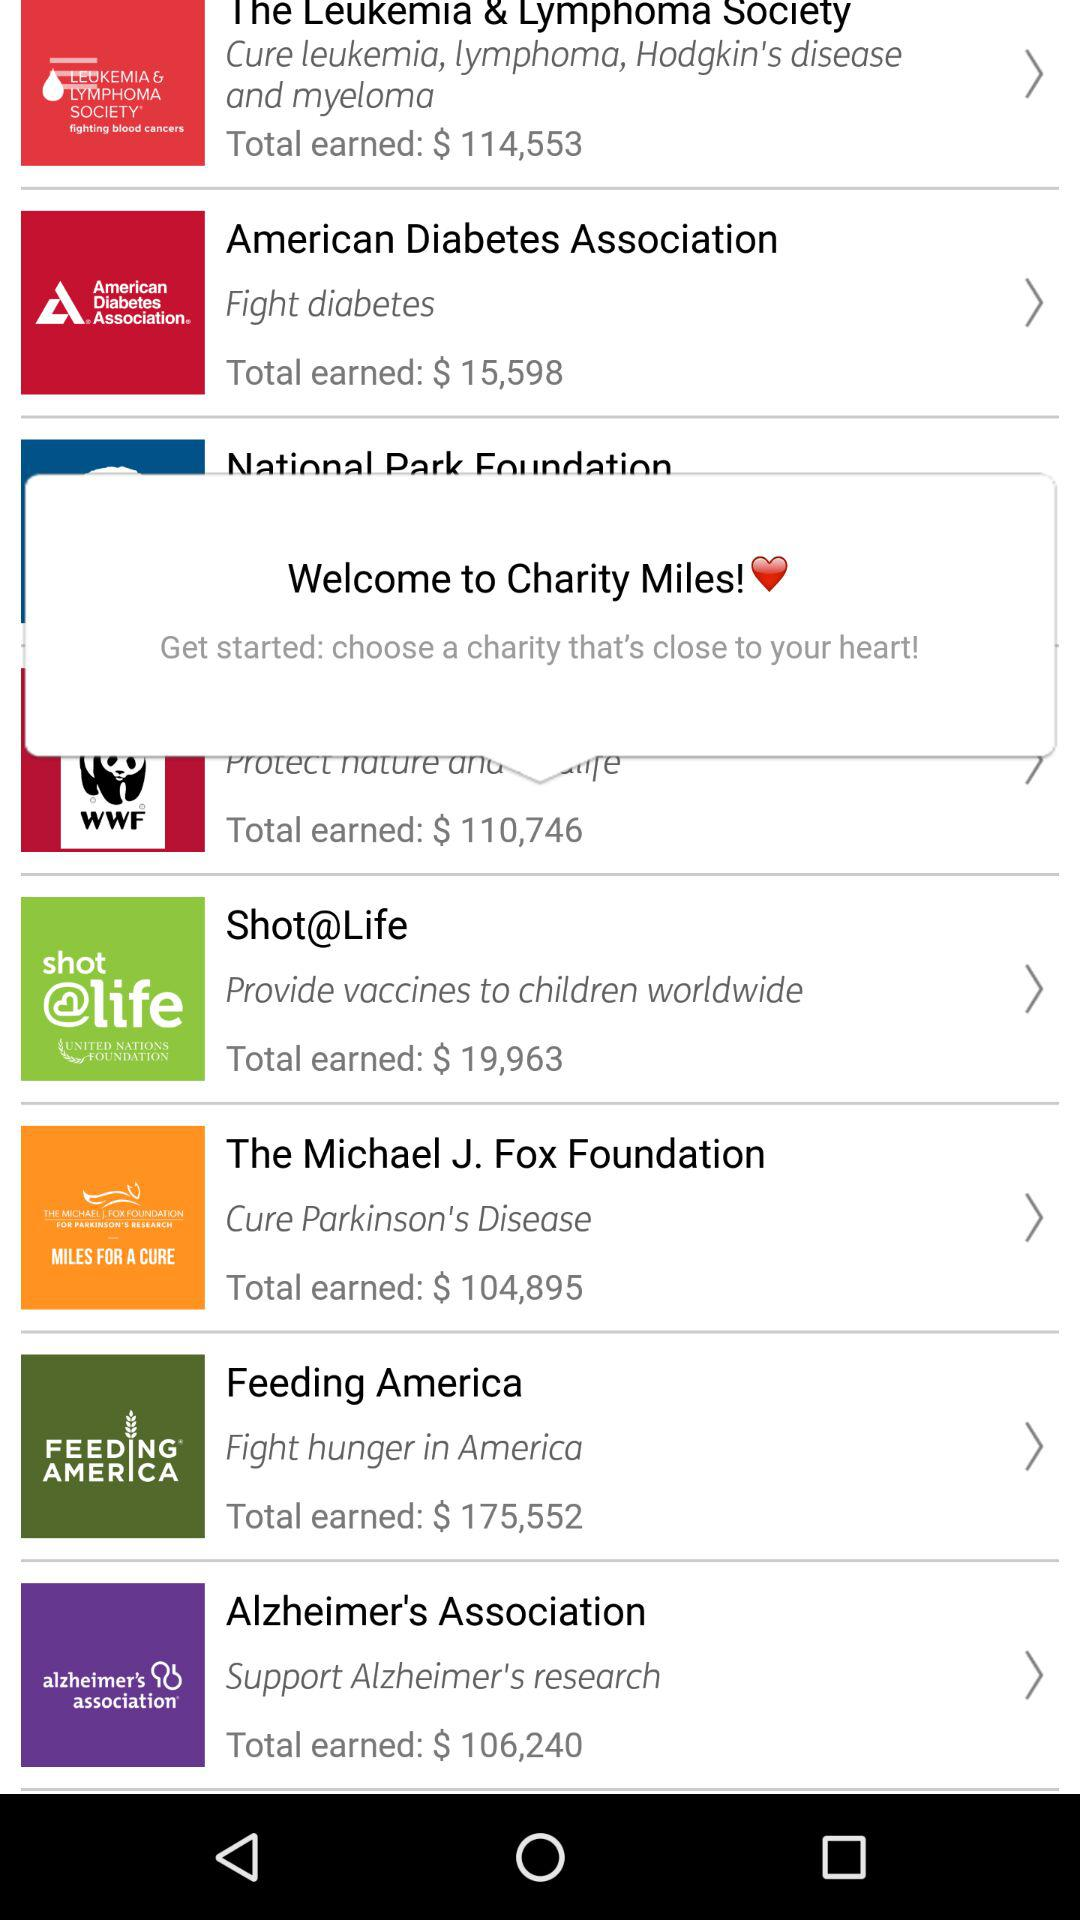Which charity is fighting hunger in America? The charity is "Feeding America". 